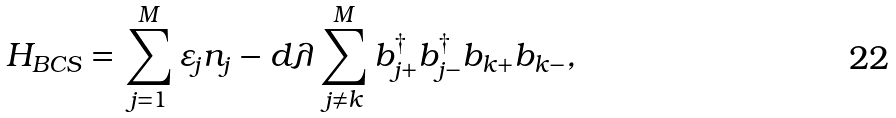Convert formula to latex. <formula><loc_0><loc_0><loc_500><loc_500>H _ { B C S } = \sum _ { j = 1 } ^ { M } \varepsilon _ { j } n _ { j } - d \lambda \sum _ { j \neq k } ^ { M } b ^ { \dagger } _ { j + } b ^ { \dagger } _ { j - } b _ { k + } b _ { k - } ,</formula> 